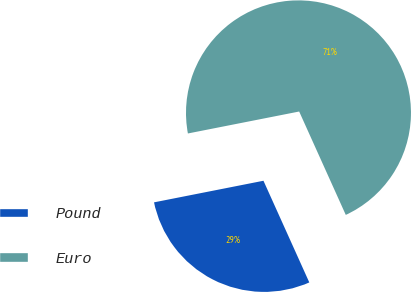<chart> <loc_0><loc_0><loc_500><loc_500><pie_chart><fcel>Pound<fcel>Euro<nl><fcel>28.64%<fcel>71.36%<nl></chart> 